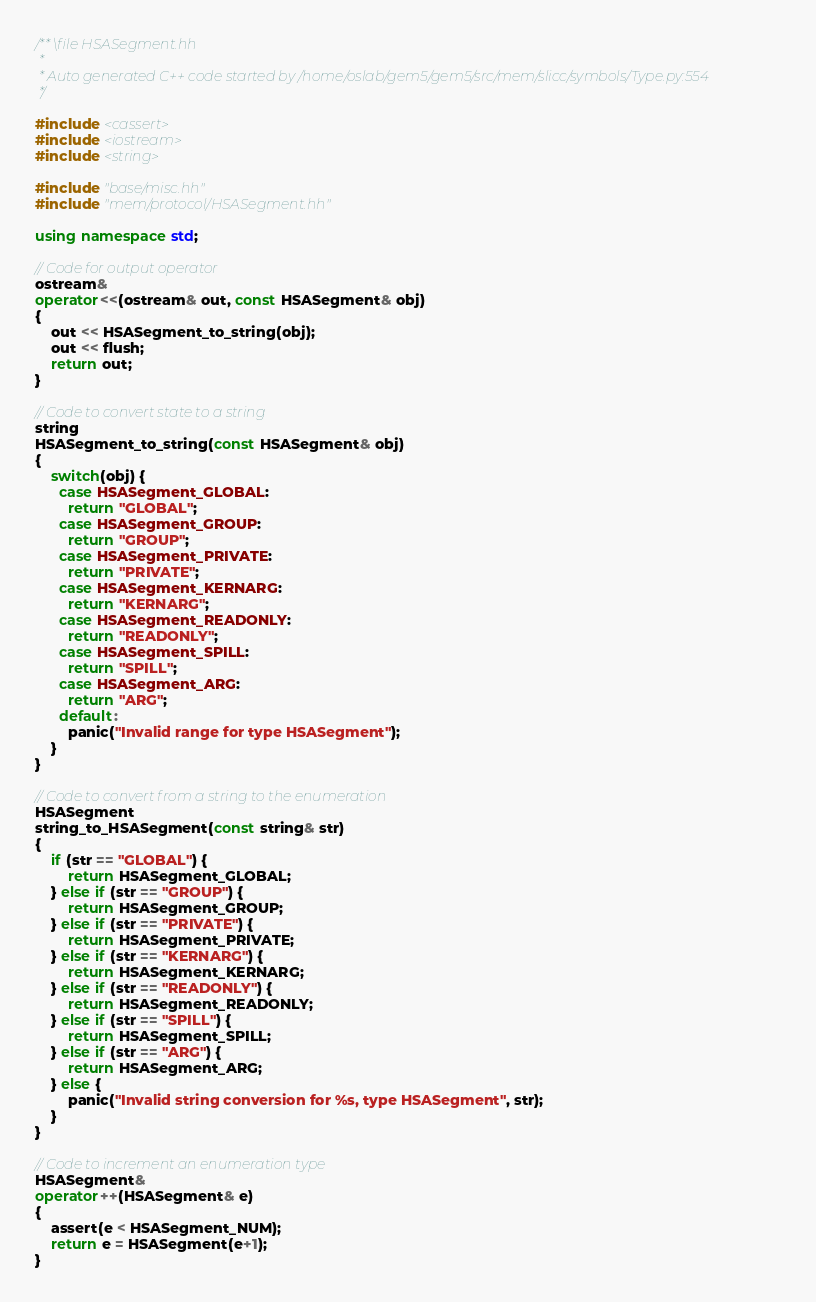Convert code to text. <code><loc_0><loc_0><loc_500><loc_500><_C++_>/** \file HSASegment.hh
 *
 * Auto generated C++ code started by /home/oslab/gem5/gem5/src/mem/slicc/symbols/Type.py:554
 */

#include <cassert>
#include <iostream>
#include <string>

#include "base/misc.hh"
#include "mem/protocol/HSASegment.hh"

using namespace std;

// Code for output operator
ostream&
operator<<(ostream& out, const HSASegment& obj)
{
    out << HSASegment_to_string(obj);
    out << flush;
    return out;
}

// Code to convert state to a string
string
HSASegment_to_string(const HSASegment& obj)
{
    switch(obj) {
      case HSASegment_GLOBAL:
        return "GLOBAL";
      case HSASegment_GROUP:
        return "GROUP";
      case HSASegment_PRIVATE:
        return "PRIVATE";
      case HSASegment_KERNARG:
        return "KERNARG";
      case HSASegment_READONLY:
        return "READONLY";
      case HSASegment_SPILL:
        return "SPILL";
      case HSASegment_ARG:
        return "ARG";
      default:
        panic("Invalid range for type HSASegment");
    }
}

// Code to convert from a string to the enumeration
HSASegment
string_to_HSASegment(const string& str)
{
    if (str == "GLOBAL") {
        return HSASegment_GLOBAL;
    } else if (str == "GROUP") {
        return HSASegment_GROUP;
    } else if (str == "PRIVATE") {
        return HSASegment_PRIVATE;
    } else if (str == "KERNARG") {
        return HSASegment_KERNARG;
    } else if (str == "READONLY") {
        return HSASegment_READONLY;
    } else if (str == "SPILL") {
        return HSASegment_SPILL;
    } else if (str == "ARG") {
        return HSASegment_ARG;
    } else {
        panic("Invalid string conversion for %s, type HSASegment", str);
    }
}

// Code to increment an enumeration type
HSASegment&
operator++(HSASegment& e)
{
    assert(e < HSASegment_NUM);
    return e = HSASegment(e+1);
}
</code> 